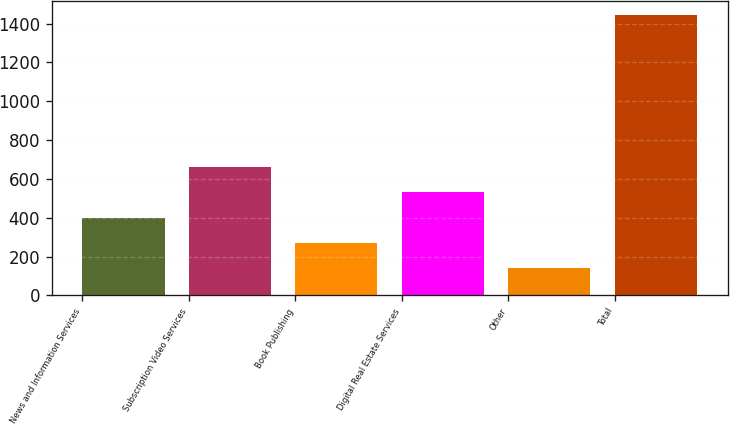Convert chart to OTSL. <chart><loc_0><loc_0><loc_500><loc_500><bar_chart><fcel>News and Information Services<fcel>Subscription Video Services<fcel>Book Publishing<fcel>Digital Real Estate Services<fcel>Other<fcel>Total<nl><fcel>399.8<fcel>660.6<fcel>269.4<fcel>530.2<fcel>139<fcel>1443<nl></chart> 